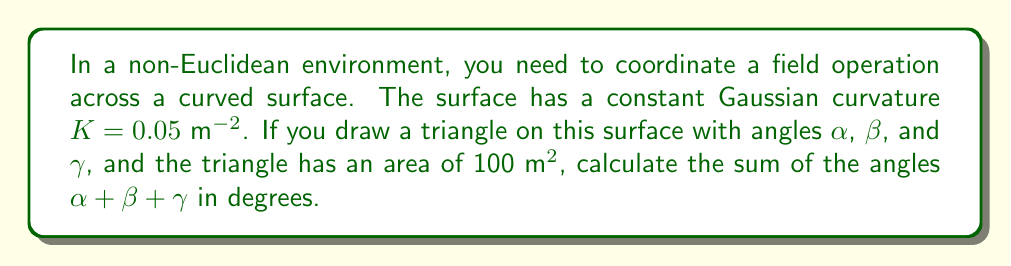Show me your answer to this math problem. Let's approach this step-by-step:

1) In non-Euclidean geometry, the sum of angles in a triangle is not always 180°. The difference from 180° is related to the curvature of the surface and the area of the triangle.

2) The relationship between the sum of angles in a triangle on a curved surface, the Gaussian curvature, and the area is given by the Gauss-Bonnet theorem:

   $$\alpha + \beta + \gamma = \pi + KA$$

   Where:
   - $\alpha$, $\beta$, and $\gamma$ are the angles of the triangle in radians
   - $K$ is the Gaussian curvature
   - $A$ is the area of the triangle

3) We are given:
   - $K = 0.05$ $m^{-2}$
   - $A = 100$ $m^2$

4) Let's substitute these values into the equation:

   $$\alpha + \beta + \gamma = \pi + (0.05 \times 100)$$

5) Simplify:

   $$\alpha + \beta + \gamma = \pi + 5 = \pi + 5 \text{ radians}$$

6) Convert to degrees:

   $$\alpha + \beta + \gamma = (\pi + 5) \times \frac{180°}{\pi} = 180° + \frac{900°}{\pi} \approx 466.4°$$

Therefore, the sum of the angles in the triangle is approximately 466.4°.
Answer: 466.4° 